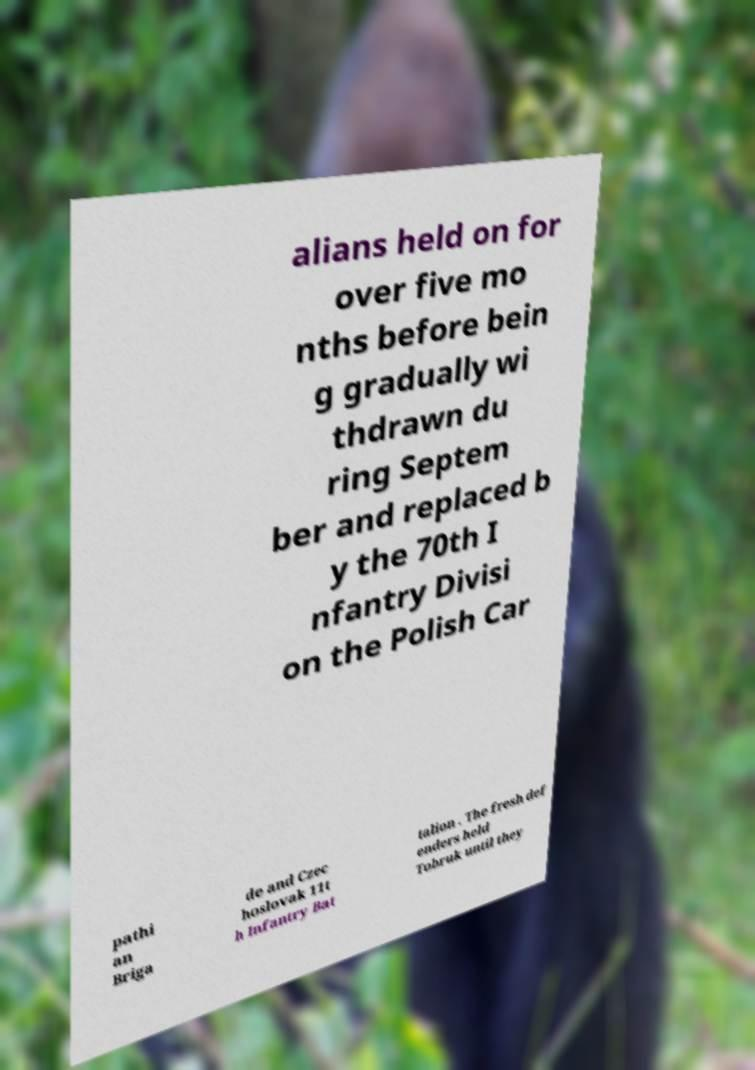For documentation purposes, I need the text within this image transcribed. Could you provide that? alians held on for over five mo nths before bein g gradually wi thdrawn du ring Septem ber and replaced b y the 70th I nfantry Divisi on the Polish Car pathi an Briga de and Czec hoslovak 11t h Infantry Bat talion . The fresh def enders held Tobruk until they 